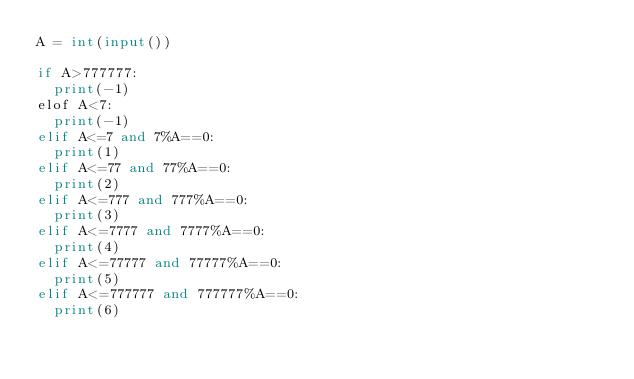<code> <loc_0><loc_0><loc_500><loc_500><_Python_>A = int(input())

if A>777777:
  print(-1)
elof A<7:
  print(-1)
elif A<=7 and 7%A==0:
  print(1)
elif A<=77 and 77%A==0:
  print(2)
elif A<=777 and 777%A==0:
  print(3)
elif A<=7777 and 7777%A==0:
  print(4)
elif A<=77777 and 77777%A==0:
  print(5)
elif A<=777777 and 777777%A==0:
  print(6)</code> 